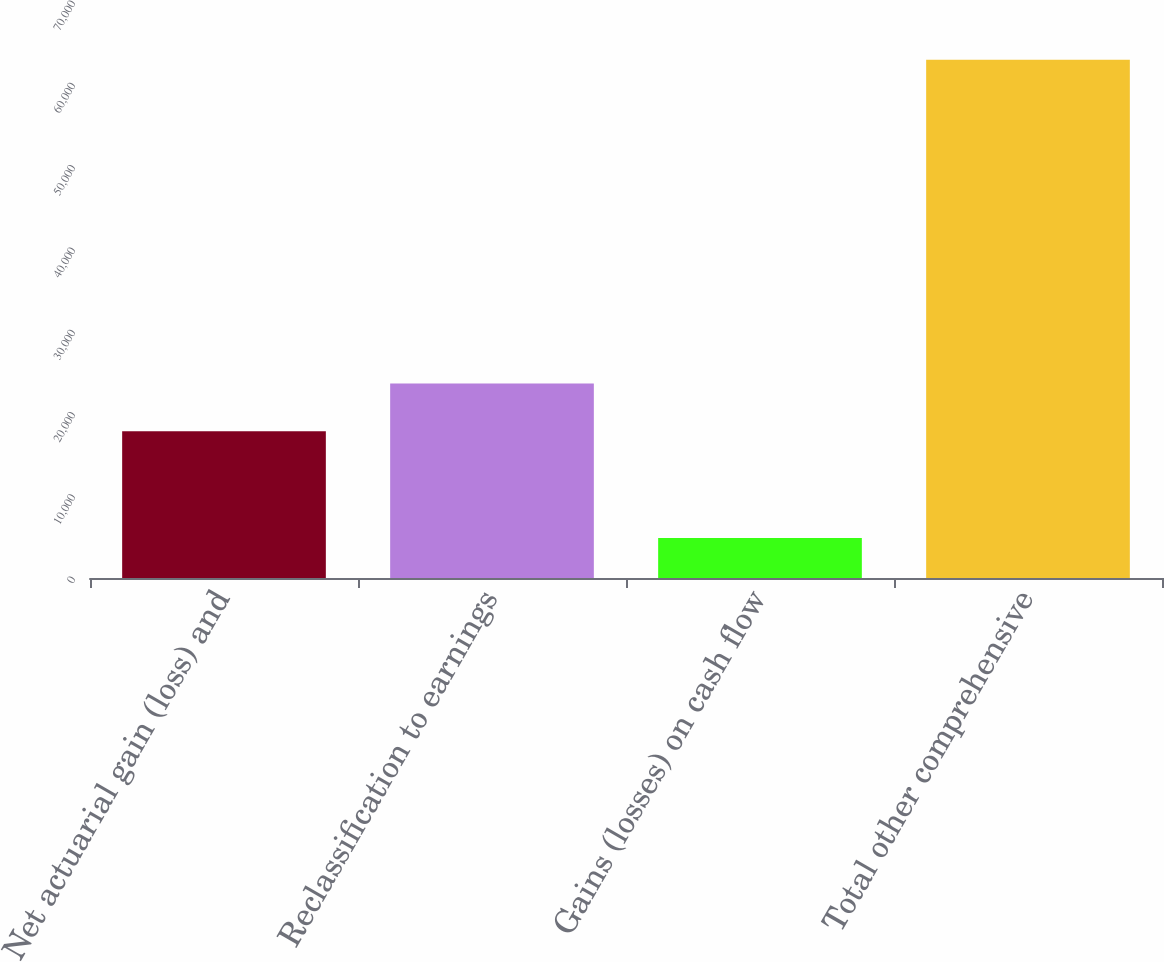<chart> <loc_0><loc_0><loc_500><loc_500><bar_chart><fcel>Net actuarial gain (loss) and<fcel>Reclassification to earnings<fcel>Gains (losses) on cash flow<fcel>Total other comprehensive<nl><fcel>17835<fcel>23647.4<fcel>4858<fcel>62982<nl></chart> 